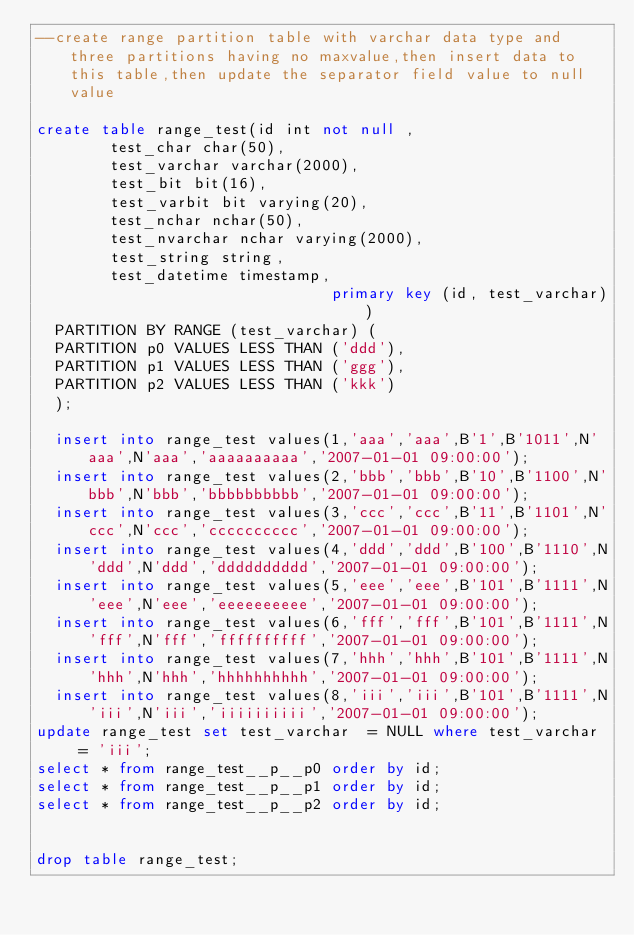<code> <loc_0><loc_0><loc_500><loc_500><_SQL_>--create range partition table with varchar data type and three partitions having no maxvalue,then insert data to this table,then update the separator field value to null value

create table range_test(id int not null ,
				test_char char(50),
				test_varchar varchar(2000),
				test_bit bit(16),
				test_varbit bit varying(20),
				test_nchar nchar(50),
				test_nvarchar nchar varying(2000),
				test_string string,
				test_datetime timestamp,
                                primary key (id, test_varchar))
	PARTITION BY RANGE (test_varchar) (
	PARTITION p0 VALUES LESS THAN ('ddd'),
	PARTITION p1 VALUES LESS THAN ('ggg'),
	PARTITION p2 VALUES LESS THAN ('kkk')
	);

	insert into range_test values(1,'aaa','aaa',B'1',B'1011',N'aaa',N'aaa','aaaaaaaaaa','2007-01-01 09:00:00');
	insert into range_test values(2,'bbb','bbb',B'10',B'1100',N'bbb',N'bbb','bbbbbbbbbb','2007-01-01 09:00:00');
	insert into range_test values(3,'ccc','ccc',B'11',B'1101',N'ccc',N'ccc','cccccccccc','2007-01-01 09:00:00');
	insert into range_test values(4,'ddd','ddd',B'100',B'1110',N'ddd',N'ddd','dddddddddd','2007-01-01 09:00:00');
	insert into range_test values(5,'eee','eee',B'101',B'1111',N'eee',N'eee','eeeeeeeeee','2007-01-01 09:00:00');
	insert into range_test values(6,'fff','fff',B'101',B'1111',N'fff',N'fff','ffffffffff','2007-01-01 09:00:00');
	insert into range_test values(7,'hhh','hhh',B'101',B'1111',N'hhh',N'hhh','hhhhhhhhhh','2007-01-01 09:00:00');
	insert into range_test values(8,'iii','iii',B'101',B'1111',N'iii',N'iii','iiiiiiiiii','2007-01-01 09:00:00');
update range_test set test_varchar  = NULL where test_varchar  = 'iii';
select * from range_test__p__p0 order by id;
select * from range_test__p__p1 order by id;
select * from range_test__p__p2 order by id;


drop table range_test;
</code> 